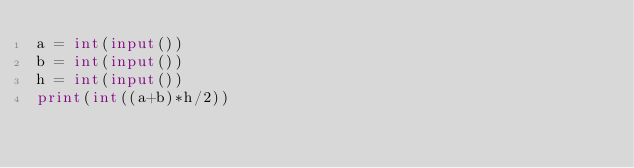<code> <loc_0><loc_0><loc_500><loc_500><_Python_>a = int(input())
b = int(input())
h = int(input())
print(int((a+b)*h/2))</code> 